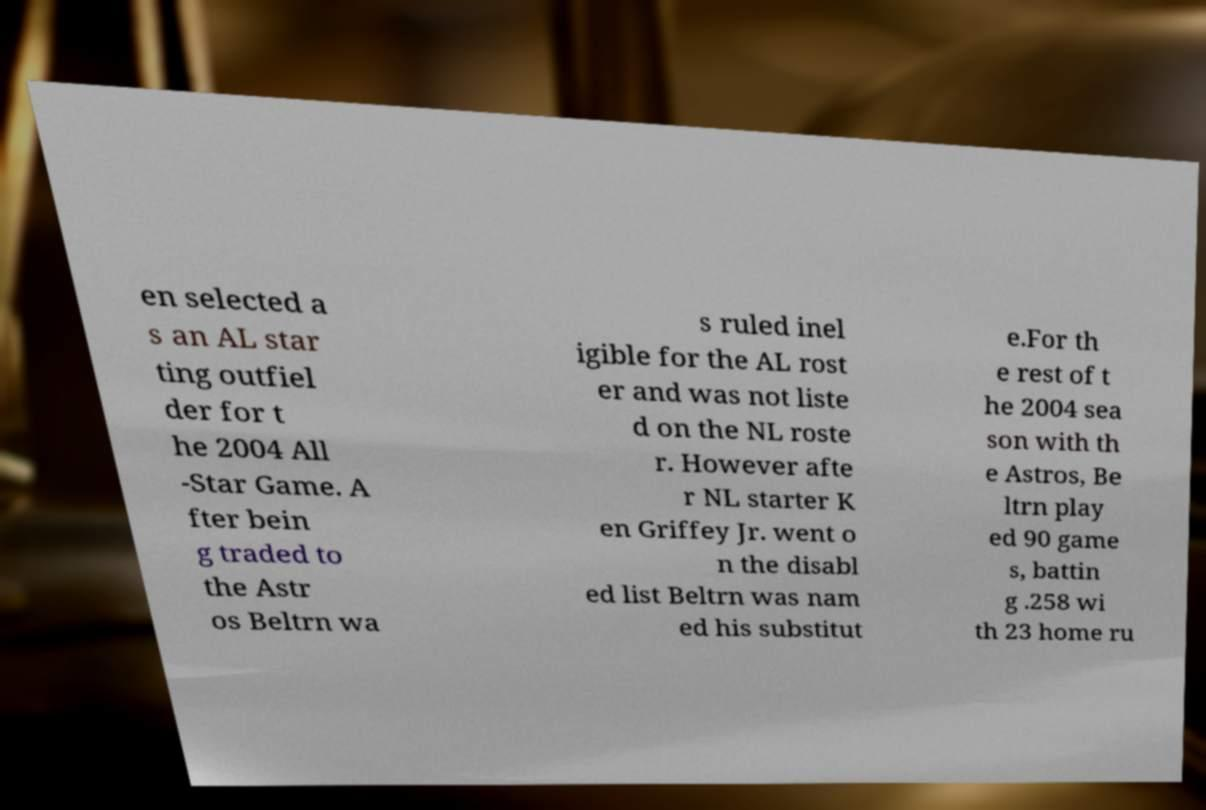For documentation purposes, I need the text within this image transcribed. Could you provide that? en selected a s an AL star ting outfiel der for t he 2004 All -Star Game. A fter bein g traded to the Astr os Beltrn wa s ruled inel igible for the AL rost er and was not liste d on the NL roste r. However afte r NL starter K en Griffey Jr. went o n the disabl ed list Beltrn was nam ed his substitut e.For th e rest of t he 2004 sea son with th e Astros, Be ltrn play ed 90 game s, battin g .258 wi th 23 home ru 